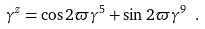<formula> <loc_0><loc_0><loc_500><loc_500>\gamma ^ { z } = \cos 2 \varpi \gamma ^ { 5 } + \sin 2 \varpi \gamma ^ { 9 } \ .</formula> 